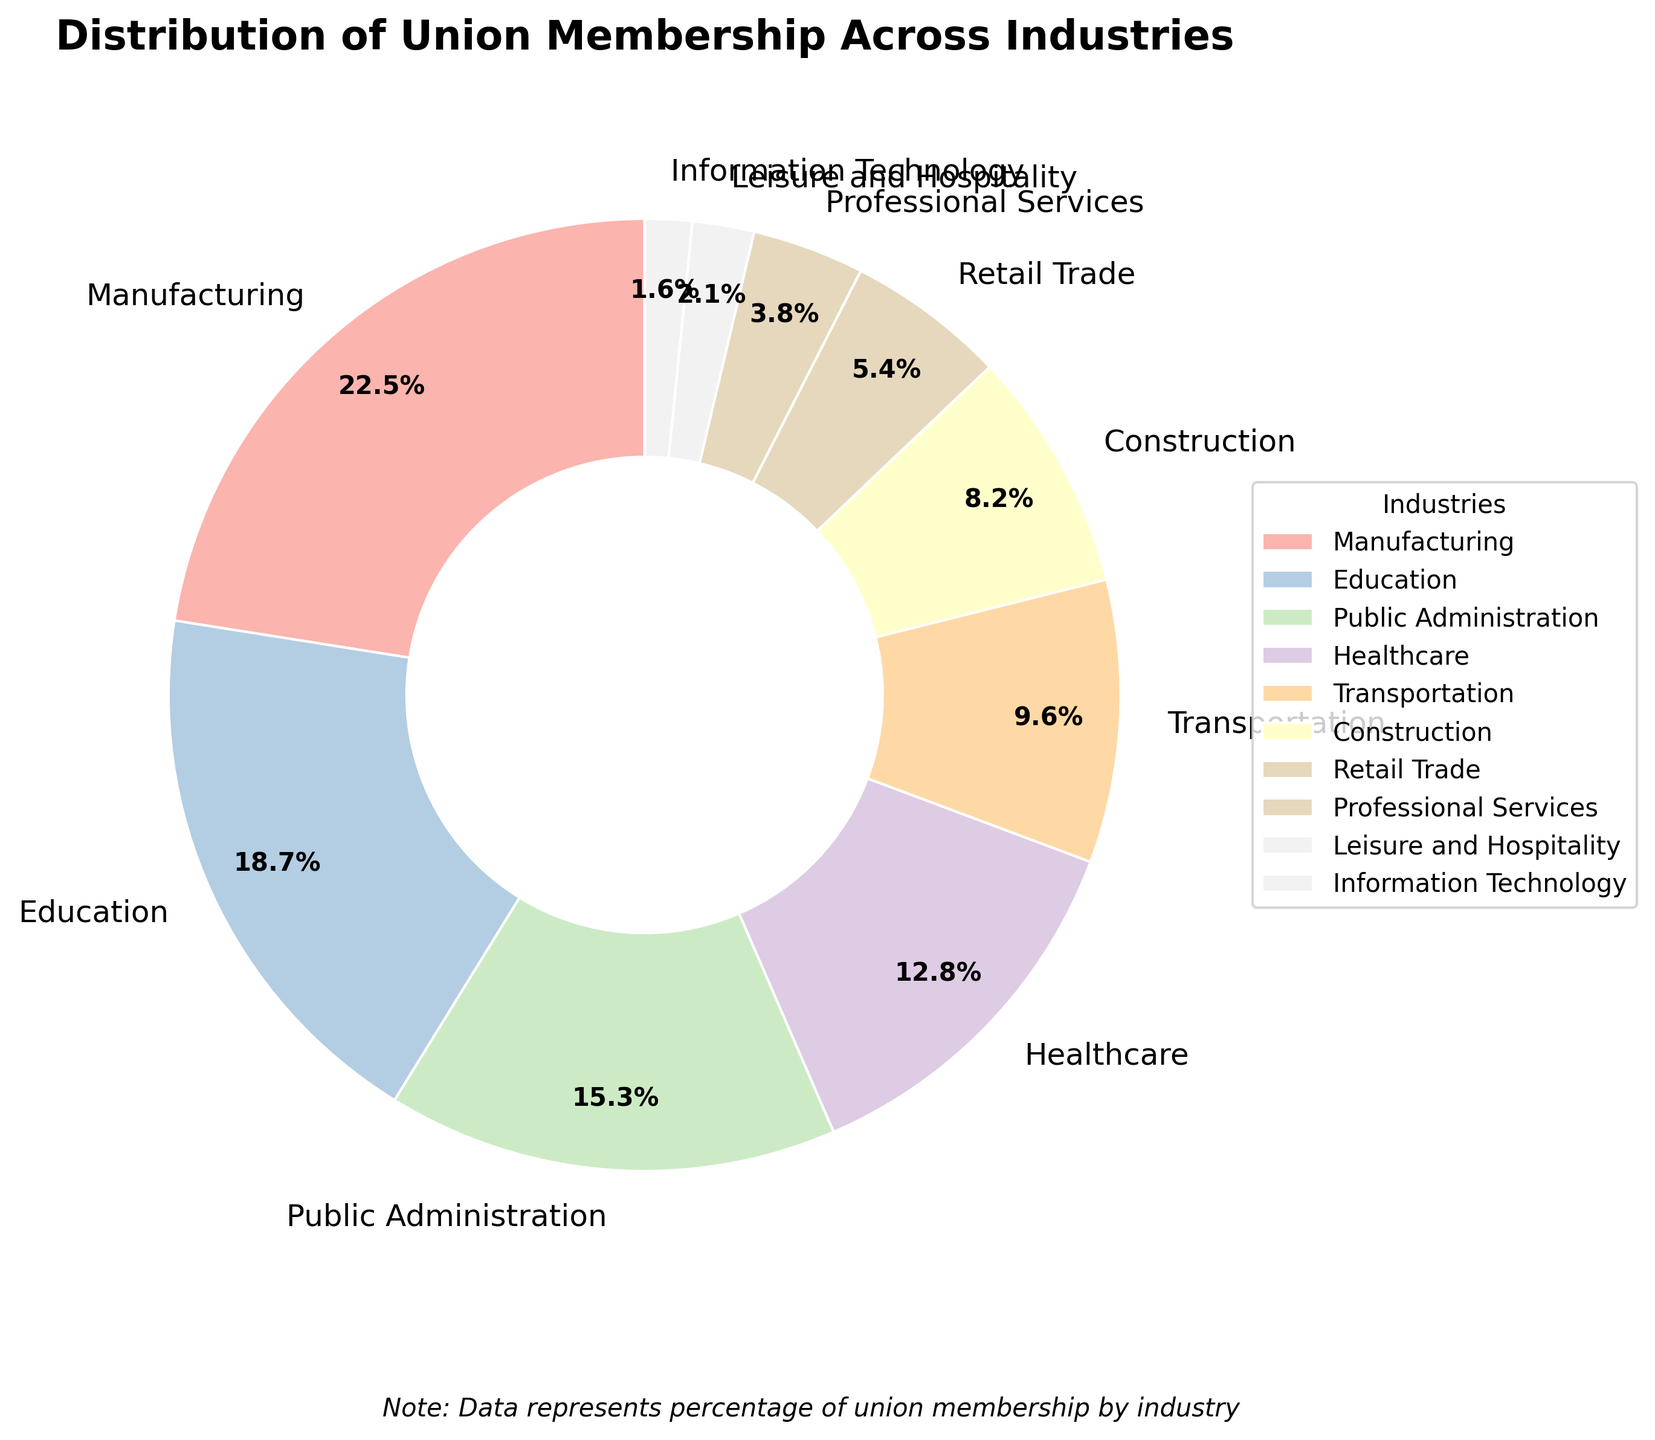Which industry has the highest percentage of union membership? The pie chart shows that the Manufacturing industry has the largest wedge, labeled with a 22.5% membership.
Answer: Manufacturing Which industries have a union membership percentage above 15%? The pie chart shows the percentages for each industry. Manufacturing (22.5%), Education (18.7%), and Public Administration (15.3%) are the ones above 15%.
Answer: Manufacturing, Education, Public Administration Which industry has the lowest percentage of union membership? The segment for Information Technology is the smallest and labeled with a 1.6% union membership.
Answer: Information Technology How much higher is the union membership percentage in Manufacturing compared to Information Technology? The union membership percentage for Manufacturing is 22.5% and for Information Technology it is 1.6%. The difference is 22.5% - 1.6% = 20.9%.
Answer: 20.9% Are there more industries with union membership percentages below 10% or above 10%? Counting the segments: Below 10% (Transportation, Construction, Retail Trade, Professional Services, Leisure and Hospitality, Information Technology) there are 6 industries. Above 10% (Manufacturing, Education, Public Administration, Healthcare) there are 4 industries.
Answer: Below 10% What is the total percentage of union membership for Healthcare, Transportation, and Construction combined? The percentages for Healthcare, Transportation, and Construction are 12.8%, 9.6%, and 8.2% respectively. Summing these, 12.8 + 9.6 + 8.2 = 30.6%.
Answer: 30.6% Which two industries combined have almost the same union membership percentage as the Public Administration industry? Public Administration has 15.3%. Looking at other industries, Healthcare and Construction combined (12.8% + 8.2% = 21.0%) and Education and Retail Trade combined (18.7% + 5.4% = 24.1%) are close but exceed. The closest combination is Transportation and Retail Trade (9.6% + 5.4% = 15.0%), nearly identical.
Answer: Transportation and Retail Trade How does the union membership in Education compare to that in Healthcare and Professional Services combined? Education has 18.7%. Healthcare and Professional Services combined have 12.8% + 3.8% = 16.6%. Education has 2.1% more membership.
Answer: 2.1% more Which color represents the Leisure and Hospitality industry in the pie chart? Look at the segment labeled "Leisure and Hospitality" which is depicted with a specific pastel slice color. The exact color could vary but is one of the slices.
Answer: (It would be one color from the pastel range represented in the pie chart) 